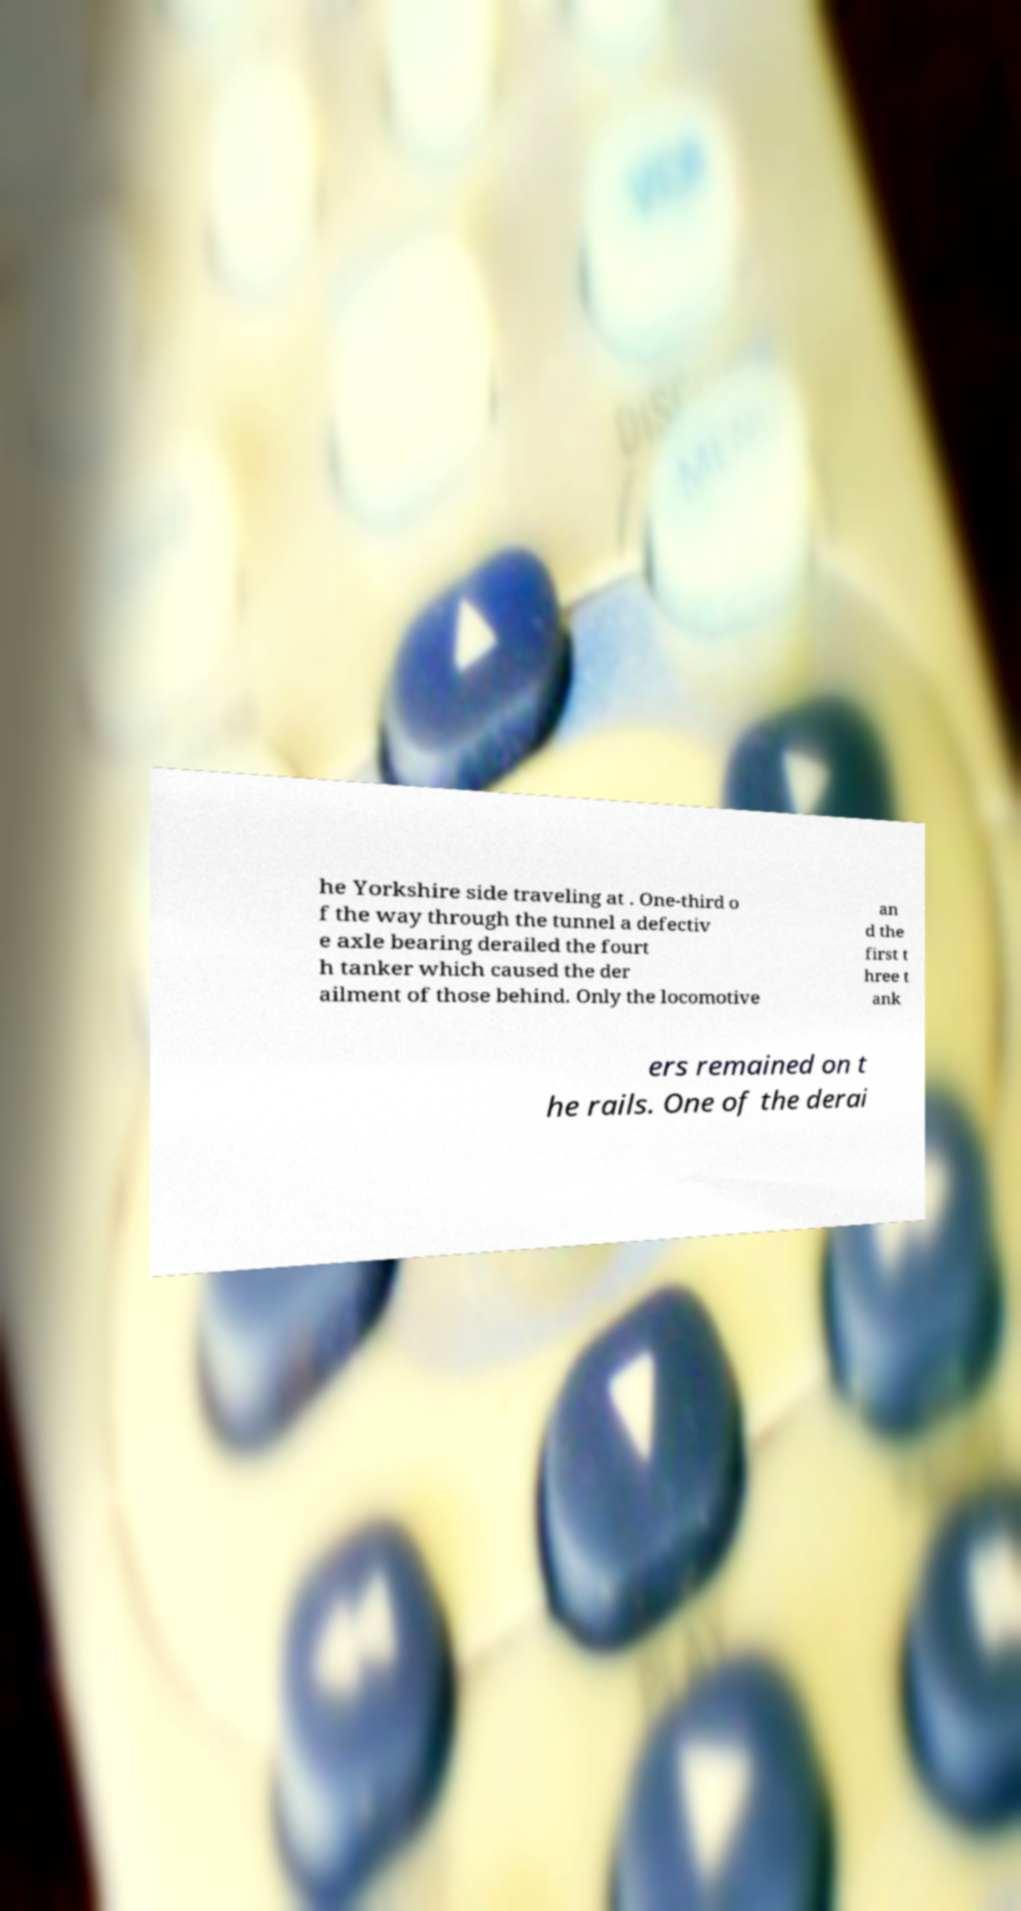Could you extract and type out the text from this image? he Yorkshire side traveling at . One-third o f the way through the tunnel a defectiv e axle bearing derailed the fourt h tanker which caused the der ailment of those behind. Only the locomotive an d the first t hree t ank ers remained on t he rails. One of the derai 